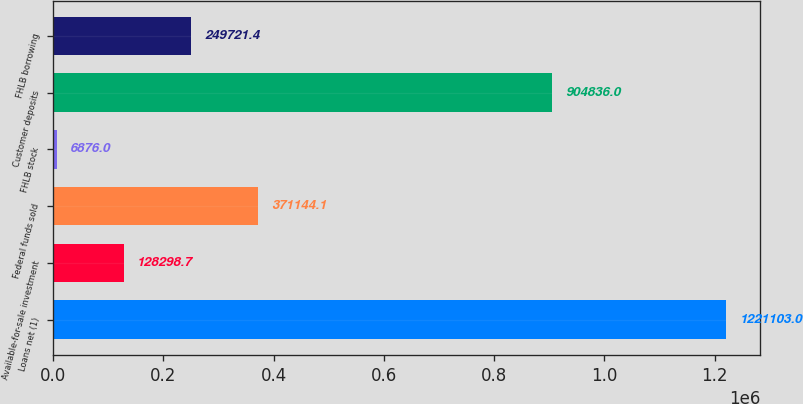Convert chart to OTSL. <chart><loc_0><loc_0><loc_500><loc_500><bar_chart><fcel>Loans net (1)<fcel>Available-for-sale investment<fcel>Federal funds sold<fcel>FHLB stock<fcel>Customer deposits<fcel>FHLB borrowing<nl><fcel>1.2211e+06<fcel>128299<fcel>371144<fcel>6876<fcel>904836<fcel>249721<nl></chart> 